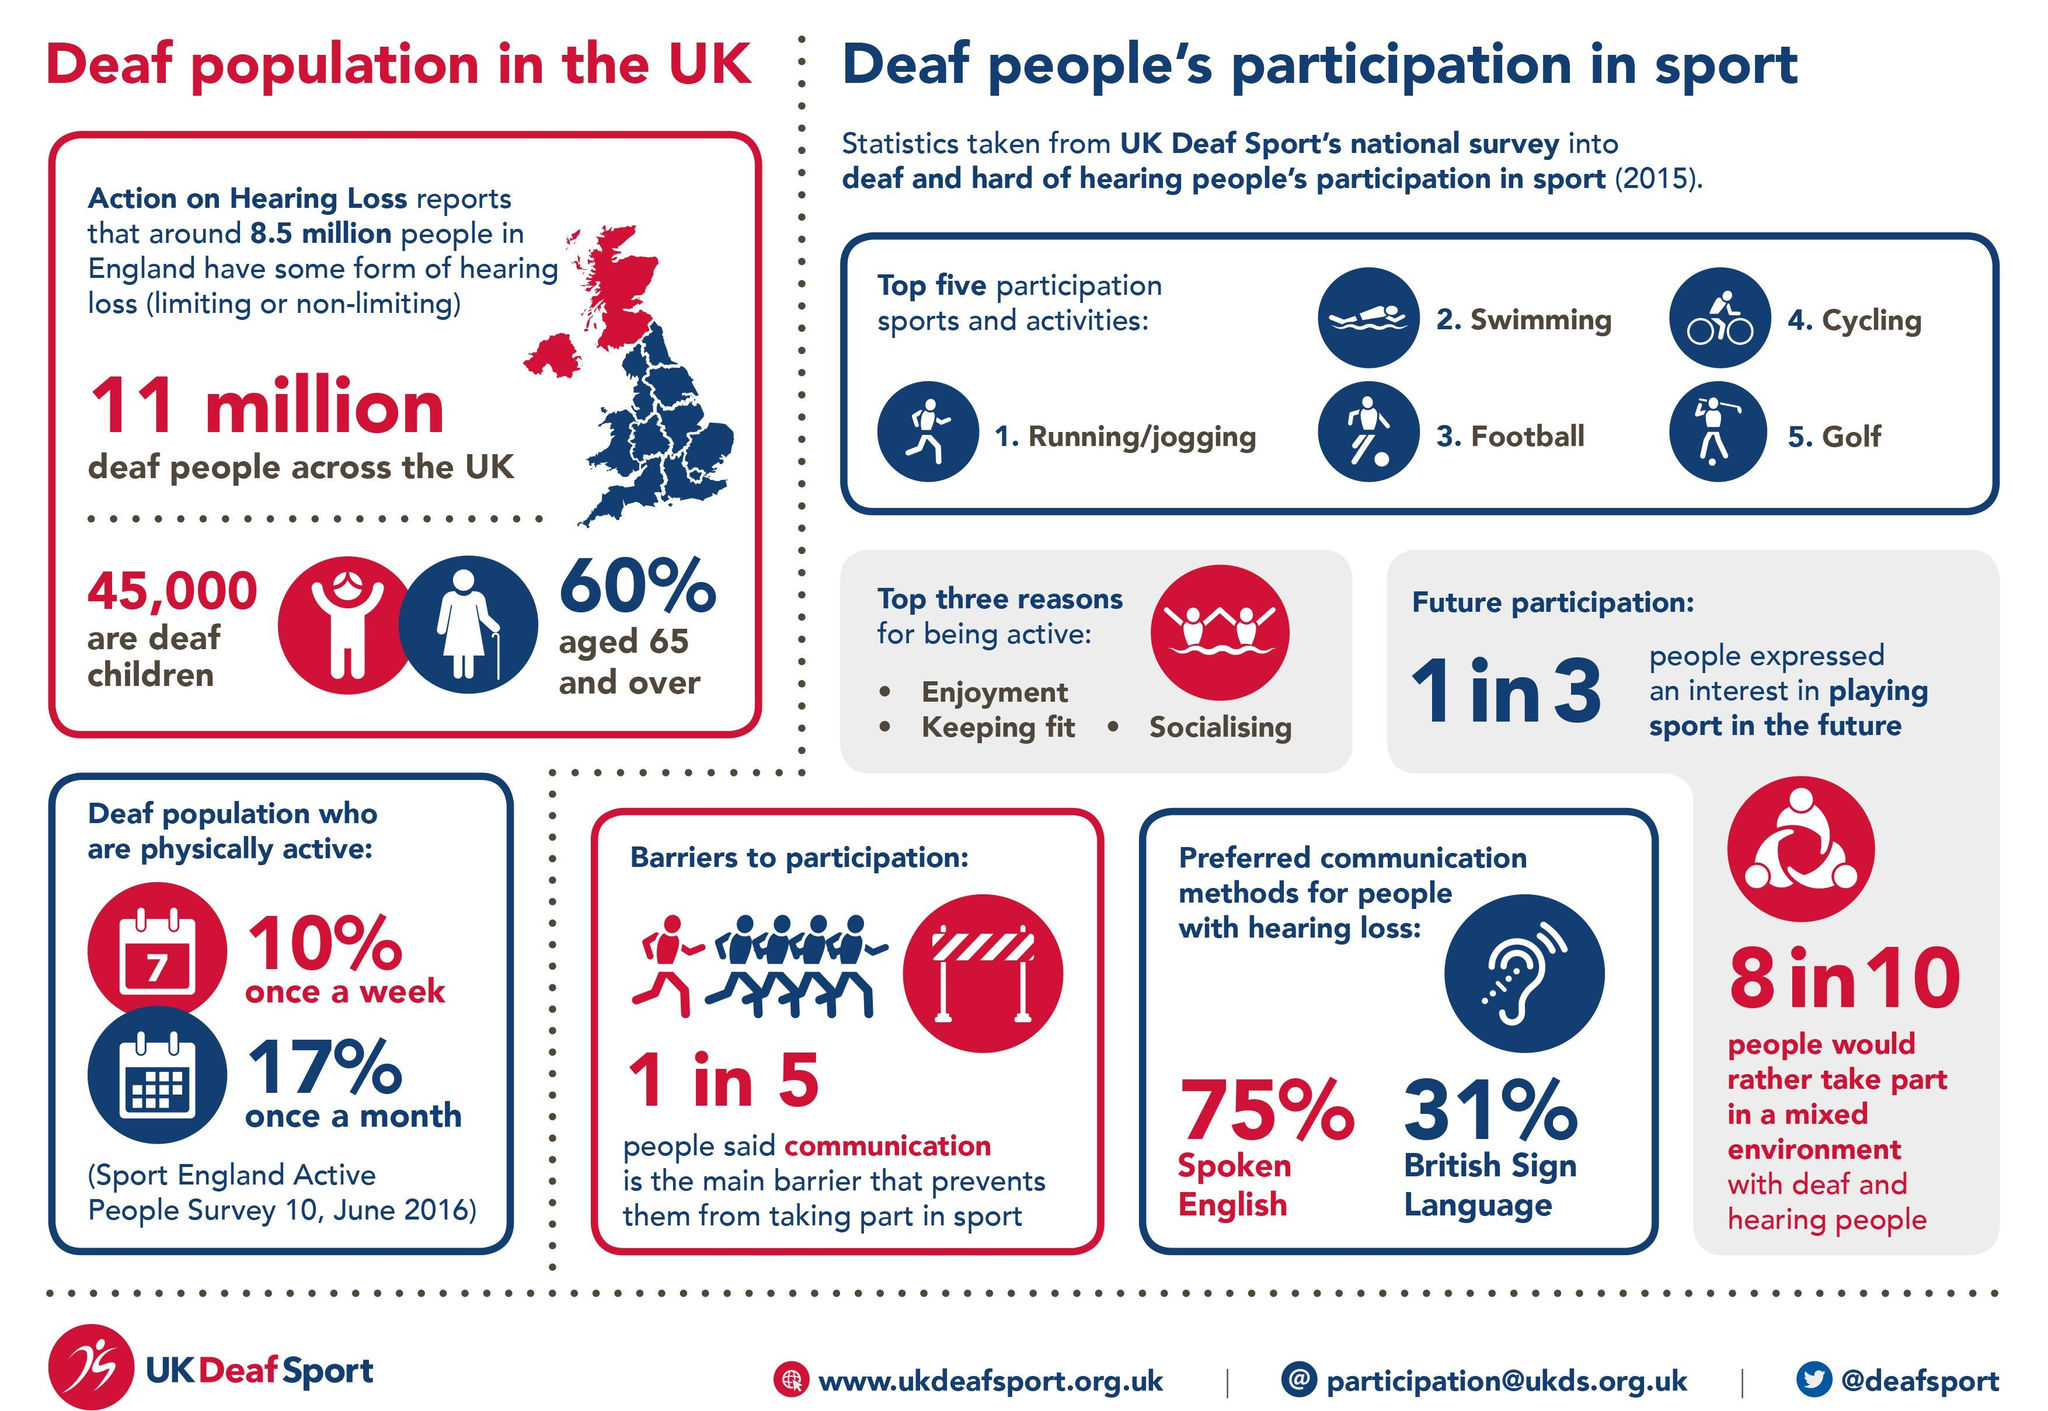Give some essential details in this illustration. Out of every three people surveyed, two did not express an interest in playing sports in the future. According to statistics, out of the 11 million deaf people living in the UK, 40% are children. The UK Deaf Sports national survey has revealed that engaging in physical activity provides numerous benefits, including increased enjoyment, improved physical fitness, and enhanced socialization opportunities. According to research, for every five people, only one individual is unable to participate in sports due to communication barriers. The most common method adopted by deaf people to communicate is sign language. 